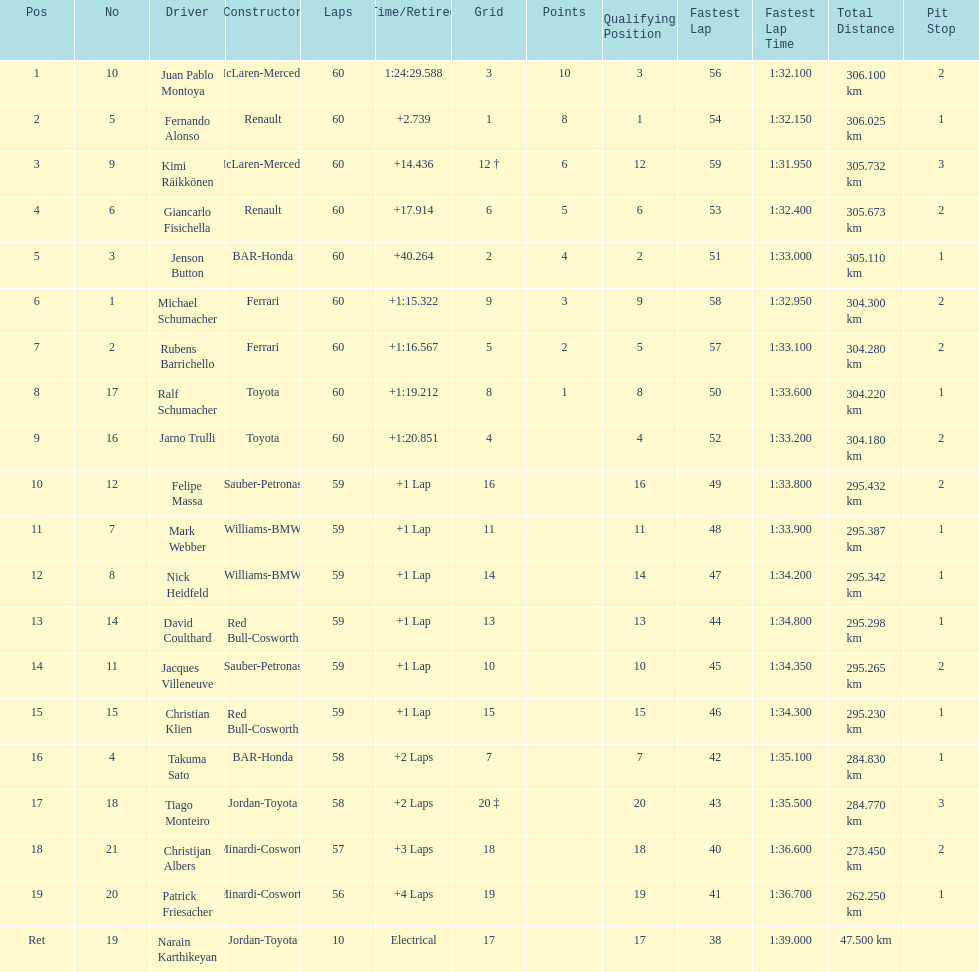Which driver in the top 8, drives a mclaran-mercedes but is not in first place? Kimi Räikkönen. 